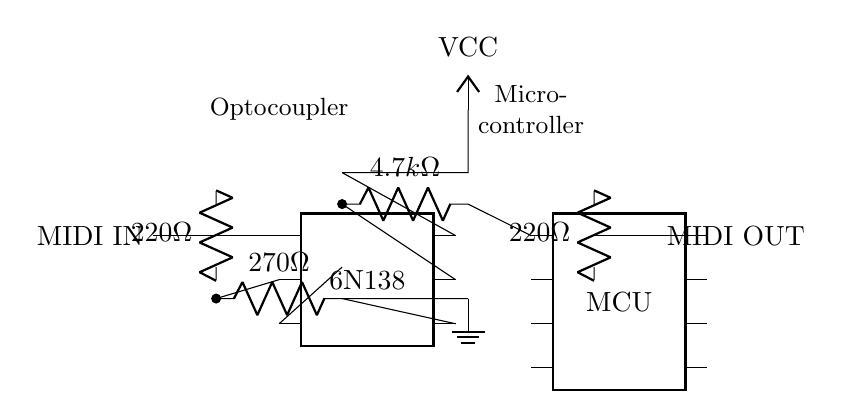What is the type of the optocoupler used? The circuit shows a 6N138 optocoupler, identifiable by its designation in the chip symbol.
Answer: 6N138 What is the resistor value connected to MIDI IN? The first resistor connected to the MIDI IN is labeled as 220 ohms, which is shown in the circuit diagram.
Answer: 220 ohms How many pins does the microcontroller have? The microcontroller is represented as an 8-pin dip chip, according to the visual representation of the component.
Answer: 8 What is the value of the resistor connected to the optocoupler's pin 5? The resistor connected to pin 5 of the optocoupler is labeled 4.7k ohms, as indicated in the circuit diagram.
Answer: 4.7k ohms What is the purpose of the optocoupler in this circuit? The optocoupler serves to isolate the MIDI IN signal from the microcontroller, protecting it from voltage spikes by providing optical isolation.
Answer: Signal isolation What is the voltage supply used in this circuit? The circuit specifies a VCC node connected at the top, indicating that the circuit is powered, typically at a standard voltage level, commonly assumed to be 5V.
Answer: 5V Which component is responsible for generating the MIDI OUT signal? The MIDI OUT signal is generated by the microcontroller, as it is connected directly to the MIDI OUT line in the circuit.
Answer: Microcontroller 